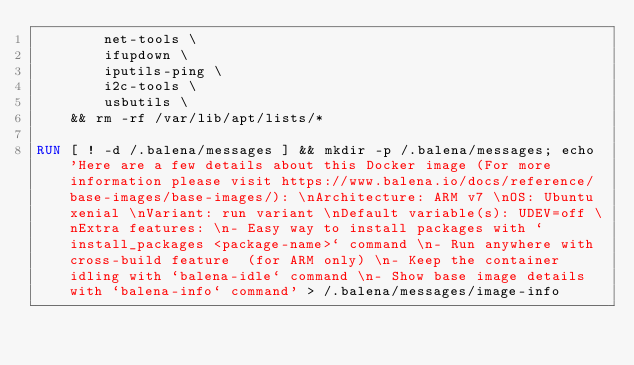Convert code to text. <code><loc_0><loc_0><loc_500><loc_500><_Dockerfile_>		net-tools \
		ifupdown \
		iputils-ping \
		i2c-tools \
		usbutils \
	&& rm -rf /var/lib/apt/lists/*

RUN [ ! -d /.balena/messages ] && mkdir -p /.balena/messages; echo 'Here are a few details about this Docker image (For more information please visit https://www.balena.io/docs/reference/base-images/base-images/): \nArchitecture: ARM v7 \nOS: Ubuntu xenial \nVariant: run variant \nDefault variable(s): UDEV=off \nExtra features: \n- Easy way to install packages with `install_packages <package-name>` command \n- Run anywhere with cross-build feature  (for ARM only) \n- Keep the container idling with `balena-idle` command \n- Show base image details with `balena-info` command' > /.balena/messages/image-info</code> 